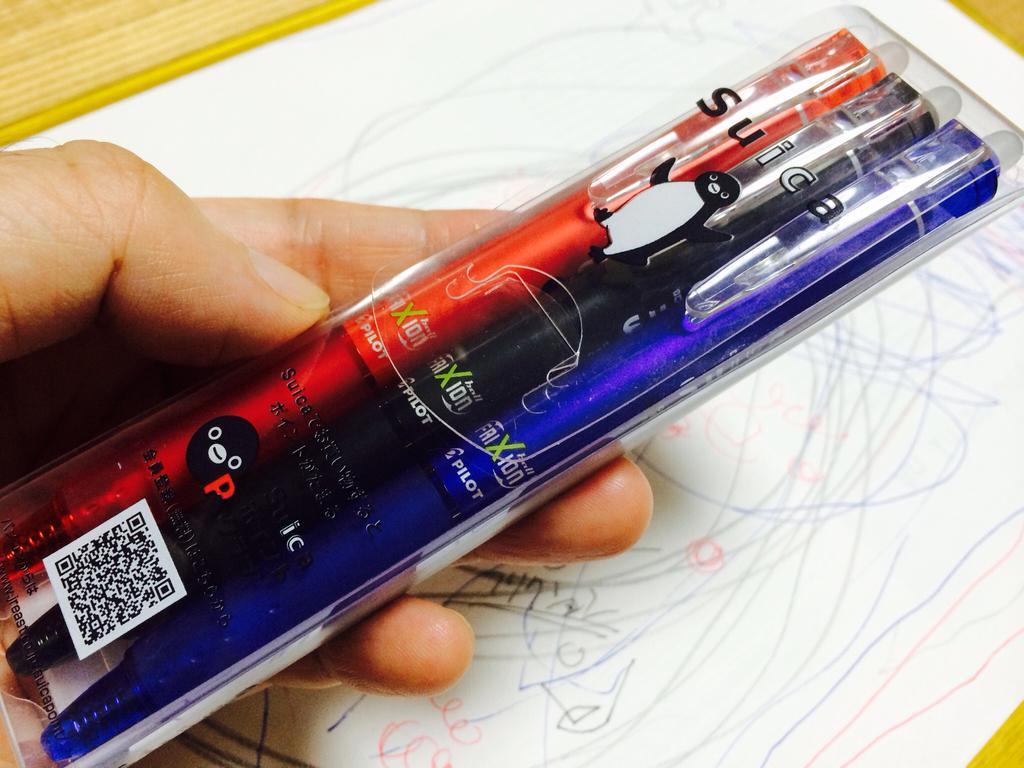How would you summarize this image in a sentence or two? In the picture we can see a table on it, we can see a white color paper with some scribbling on it and on it we can see a person's hand holding a pens packet with pens which are blue, black and red in color and on the packet we can see a code. 